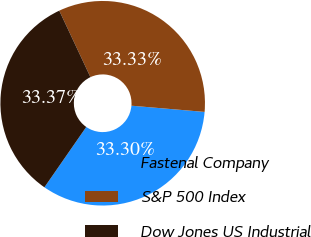<chart> <loc_0><loc_0><loc_500><loc_500><pie_chart><fcel>Fastenal Company<fcel>S&P 500 Index<fcel>Dow Jones US Industrial<nl><fcel>33.3%<fcel>33.33%<fcel>33.37%<nl></chart> 